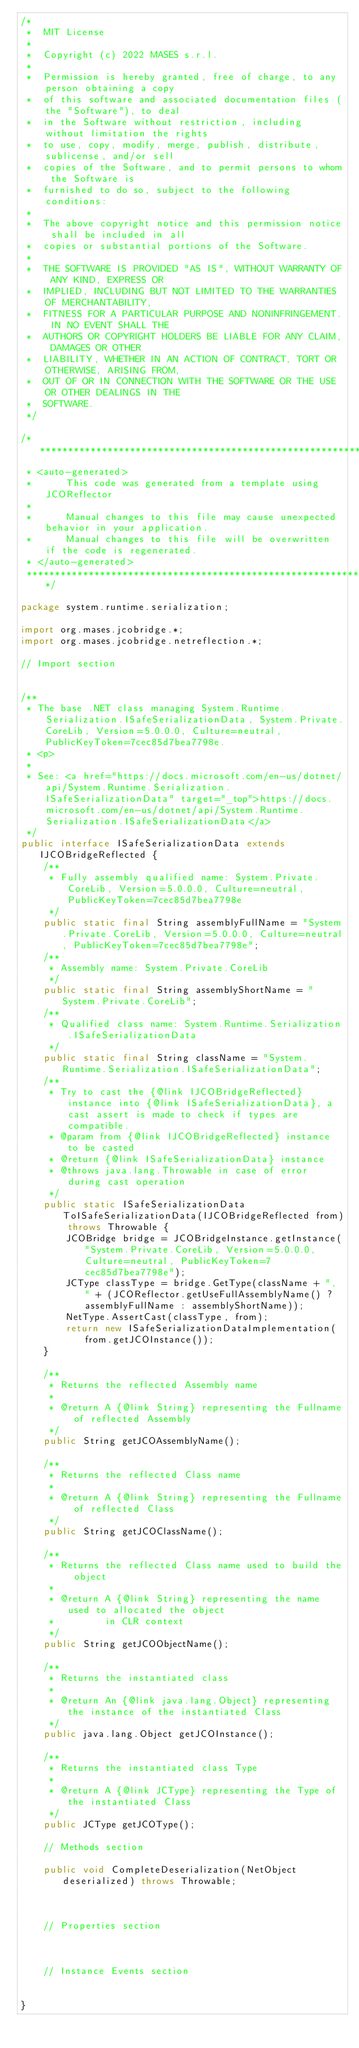Convert code to text. <code><loc_0><loc_0><loc_500><loc_500><_Java_>/*
 *  MIT License
 *
 *  Copyright (c) 2022 MASES s.r.l.
 *
 *  Permission is hereby granted, free of charge, to any person obtaining a copy
 *  of this software and associated documentation files (the "Software"), to deal
 *  in the Software without restriction, including without limitation the rights
 *  to use, copy, modify, merge, publish, distribute, sublicense, and/or sell
 *  copies of the Software, and to permit persons to whom the Software is
 *  furnished to do so, subject to the following conditions:
 *
 *  The above copyright notice and this permission notice shall be included in all
 *  copies or substantial portions of the Software.
 *
 *  THE SOFTWARE IS PROVIDED "AS IS", WITHOUT WARRANTY OF ANY KIND, EXPRESS OR
 *  IMPLIED, INCLUDING BUT NOT LIMITED TO THE WARRANTIES OF MERCHANTABILITY,
 *  FITNESS FOR A PARTICULAR PURPOSE AND NONINFRINGEMENT. IN NO EVENT SHALL THE
 *  AUTHORS OR COPYRIGHT HOLDERS BE LIABLE FOR ANY CLAIM, DAMAGES OR OTHER
 *  LIABILITY, WHETHER IN AN ACTION OF CONTRACT, TORT OR OTHERWISE, ARISING FROM,
 *  OUT OF OR IN CONNECTION WITH THE SOFTWARE OR THE USE OR OTHER DEALINGS IN THE
 *  SOFTWARE.
 */

/**************************************************************************************
 * <auto-generated>
 *      This code was generated from a template using JCOReflector
 * 
 *      Manual changes to this file may cause unexpected behavior in your application.
 *      Manual changes to this file will be overwritten if the code is regenerated.
 * </auto-generated>
 *************************************************************************************/

package system.runtime.serialization;

import org.mases.jcobridge.*;
import org.mases.jcobridge.netreflection.*;

// Import section


/**
 * The base .NET class managing System.Runtime.Serialization.ISafeSerializationData, System.Private.CoreLib, Version=5.0.0.0, Culture=neutral, PublicKeyToken=7cec85d7bea7798e.
 * <p>
 * 
 * See: <a href="https://docs.microsoft.com/en-us/dotnet/api/System.Runtime.Serialization.ISafeSerializationData" target="_top">https://docs.microsoft.com/en-us/dotnet/api/System.Runtime.Serialization.ISafeSerializationData</a>
 */
public interface ISafeSerializationData extends IJCOBridgeReflected {
    /**
     * Fully assembly qualified name: System.Private.CoreLib, Version=5.0.0.0, Culture=neutral, PublicKeyToken=7cec85d7bea7798e
     */
    public static final String assemblyFullName = "System.Private.CoreLib, Version=5.0.0.0, Culture=neutral, PublicKeyToken=7cec85d7bea7798e";
    /**
     * Assembly name: System.Private.CoreLib
     */
    public static final String assemblyShortName = "System.Private.CoreLib";
    /**
     * Qualified class name: System.Runtime.Serialization.ISafeSerializationData
     */
    public static final String className = "System.Runtime.Serialization.ISafeSerializationData";
    /**
     * Try to cast the {@link IJCOBridgeReflected} instance into {@link ISafeSerializationData}, a cast assert is made to check if types are compatible.
     * @param from {@link IJCOBridgeReflected} instance to be casted
     * @return {@link ISafeSerializationData} instance
     * @throws java.lang.Throwable in case of error during cast operation
     */
    public static ISafeSerializationData ToISafeSerializationData(IJCOBridgeReflected from) throws Throwable {
        JCOBridge bridge = JCOBridgeInstance.getInstance("System.Private.CoreLib, Version=5.0.0.0, Culture=neutral, PublicKeyToken=7cec85d7bea7798e");
        JCType classType = bridge.GetType(className + ", " + (JCOReflector.getUseFullAssemblyName() ? assemblyFullName : assemblyShortName));
        NetType.AssertCast(classType, from);
        return new ISafeSerializationDataImplementation(from.getJCOInstance());
    }

    /**
     * Returns the reflected Assembly name
     * 
     * @return A {@link String} representing the Fullname of reflected Assembly
     */
    public String getJCOAssemblyName();

    /**
     * Returns the reflected Class name
     * 
     * @return A {@link String} representing the Fullname of reflected Class
     */
    public String getJCOClassName();

    /**
     * Returns the reflected Class name used to build the object
     * 
     * @return A {@link String} representing the name used to allocated the object
     *         in CLR context
     */
    public String getJCOObjectName();

    /**
     * Returns the instantiated class
     * 
     * @return An {@link java.lang.Object} representing the instance of the instantiated Class
     */
    public java.lang.Object getJCOInstance();

    /**
     * Returns the instantiated class Type
     * 
     * @return A {@link JCType} representing the Type of the instantiated Class
     */
    public JCType getJCOType();

    // Methods section
    
    public void CompleteDeserialization(NetObject deserialized) throws Throwable;


    
    // Properties section
    


    // Instance Events section
    

}</code> 